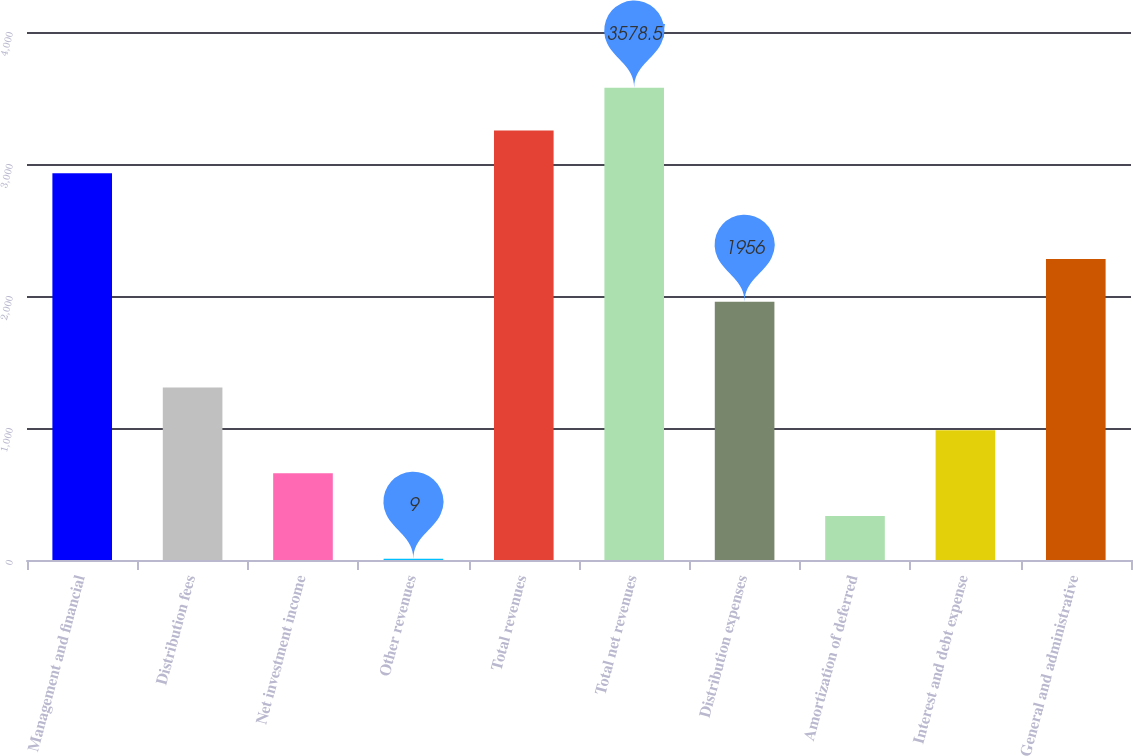<chart> <loc_0><loc_0><loc_500><loc_500><bar_chart><fcel>Management and financial<fcel>Distribution fees<fcel>Net investment income<fcel>Other revenues<fcel>Total revenues<fcel>Total net revenues<fcel>Distribution expenses<fcel>Amortization of deferred<fcel>Interest and debt expense<fcel>General and administrative<nl><fcel>2929.5<fcel>1307<fcel>658<fcel>9<fcel>3254<fcel>3578.5<fcel>1956<fcel>333.5<fcel>982.5<fcel>2280.5<nl></chart> 